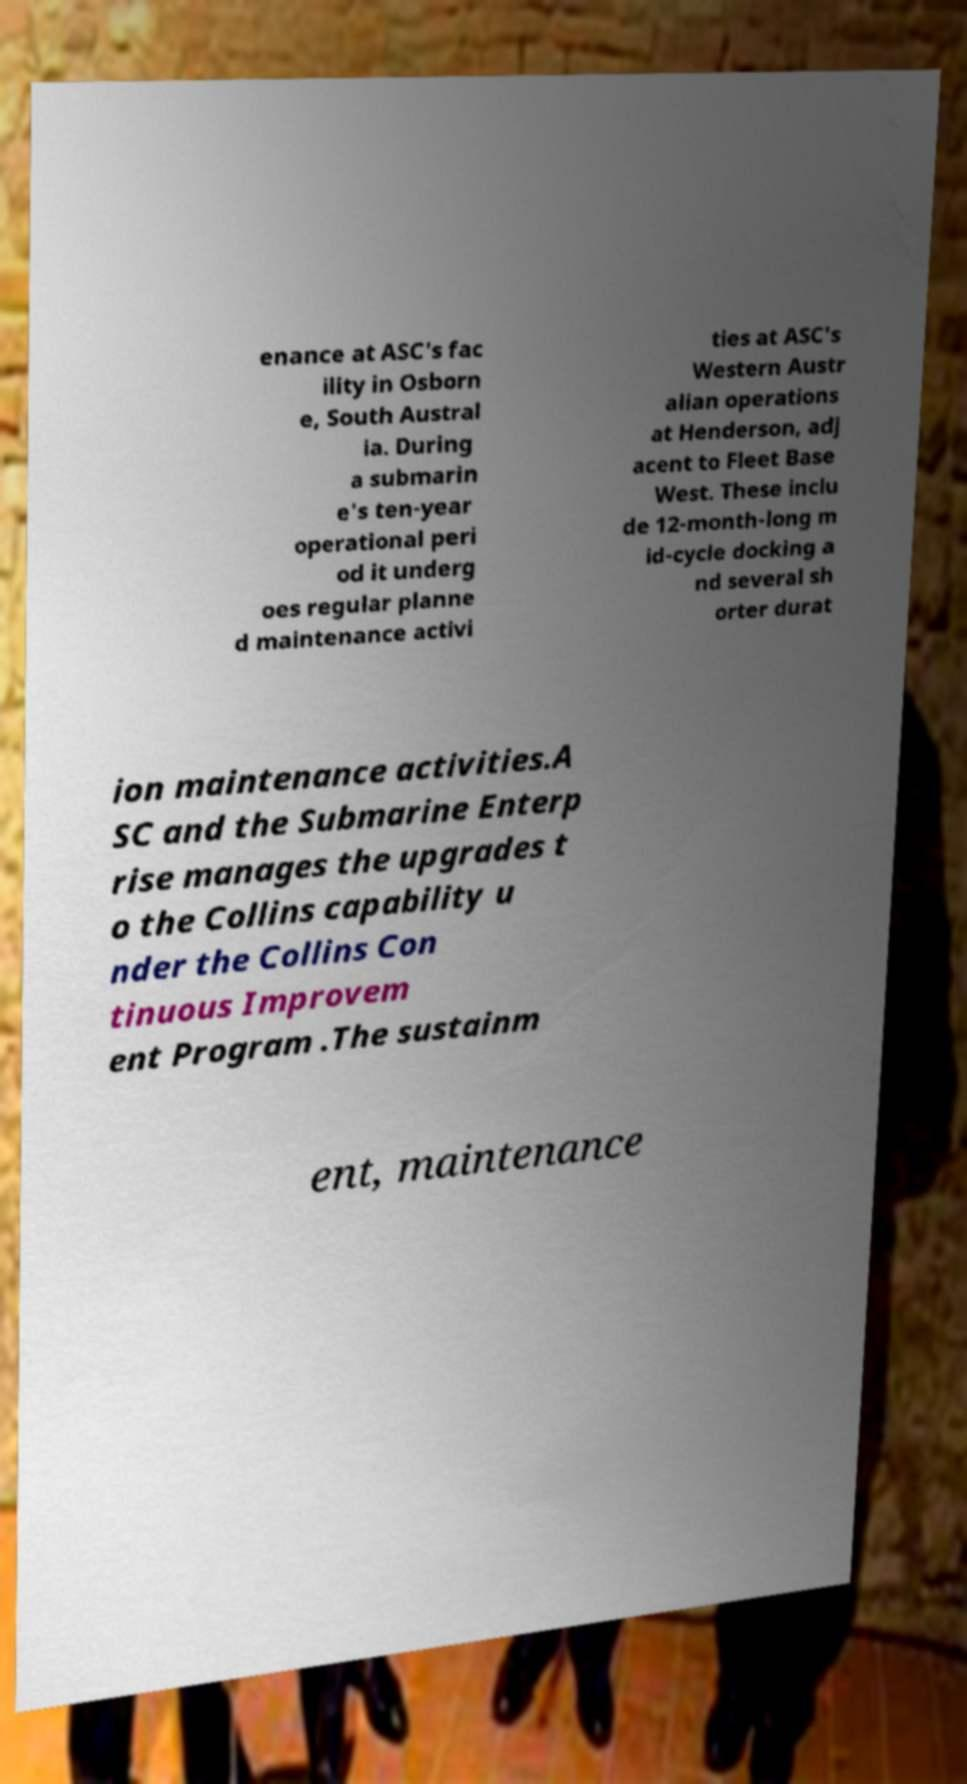Please identify and transcribe the text found in this image. enance at ASC's fac ility in Osborn e, South Austral ia. During a submarin e's ten-year operational peri od it underg oes regular planne d maintenance activi ties at ASC's Western Austr alian operations at Henderson, adj acent to Fleet Base West. These inclu de 12-month-long m id-cycle docking a nd several sh orter durat ion maintenance activities.A SC and the Submarine Enterp rise manages the upgrades t o the Collins capability u nder the Collins Con tinuous Improvem ent Program .The sustainm ent, maintenance 